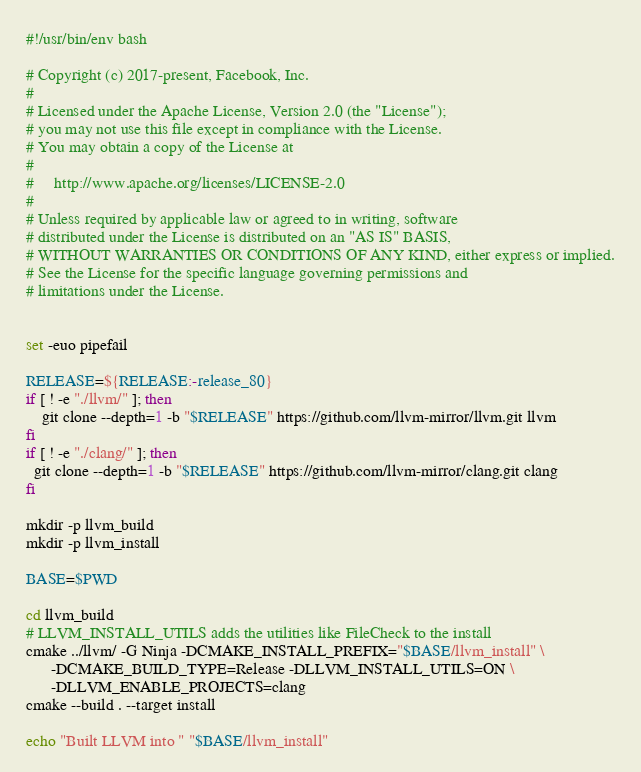Convert code to text. <code><loc_0><loc_0><loc_500><loc_500><_Bash_>#!/usr/bin/env bash

# Copyright (c) 2017-present, Facebook, Inc.
#
# Licensed under the Apache License, Version 2.0 (the "License");
# you may not use this file except in compliance with the License.
# You may obtain a copy of the License at
#
#     http://www.apache.org/licenses/LICENSE-2.0
#
# Unless required by applicable law or agreed to in writing, software
# distributed under the License is distributed on an "AS IS" BASIS,
# WITHOUT WARRANTIES OR CONDITIONS OF ANY KIND, either express or implied.
# See the License for the specific language governing permissions and
# limitations under the License.


set -euo pipefail

RELEASE=${RELEASE:-release_80}
if [ ! -e "./llvm/" ]; then
    git clone --depth=1 -b "$RELEASE" https://github.com/llvm-mirror/llvm.git llvm
fi
if [ ! -e "./clang/" ]; then
  git clone --depth=1 -b "$RELEASE" https://github.com/llvm-mirror/clang.git clang
fi

mkdir -p llvm_build
mkdir -p llvm_install

BASE=$PWD

cd llvm_build
# LLVM_INSTALL_UTILS adds the utilities like FileCheck to the install
cmake ../llvm/ -G Ninja -DCMAKE_INSTALL_PREFIX="$BASE/llvm_install" \
      -DCMAKE_BUILD_TYPE=Release -DLLVM_INSTALL_UTILS=ON \
      -DLLVM_ENABLE_PROJECTS=clang
cmake --build . --target install

echo "Built LLVM into " "$BASE/llvm_install"
</code> 